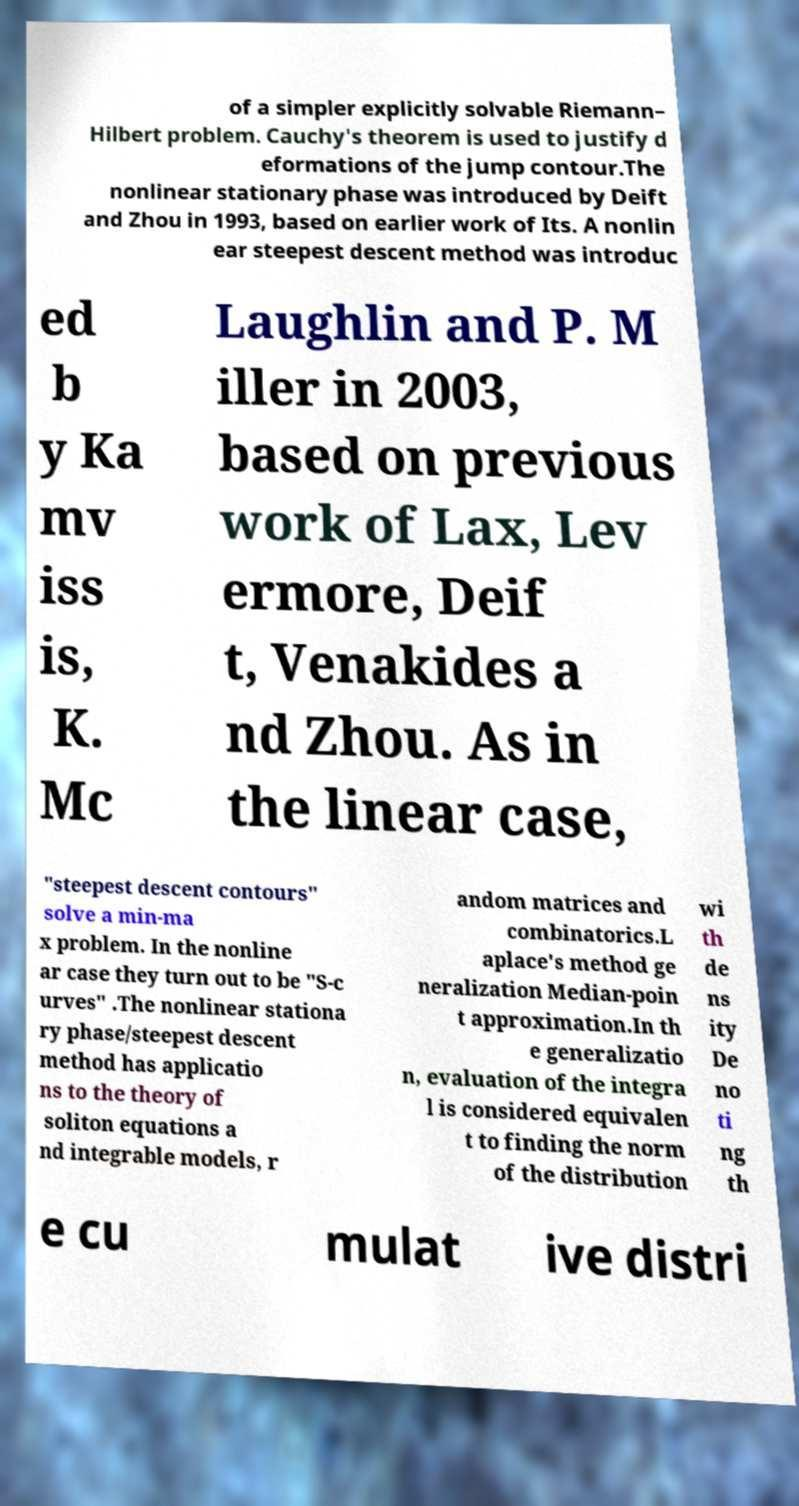Can you read and provide the text displayed in the image?This photo seems to have some interesting text. Can you extract and type it out for me? of a simpler explicitly solvable Riemann– Hilbert problem. Cauchy's theorem is used to justify d eformations of the jump contour.The nonlinear stationary phase was introduced by Deift and Zhou in 1993, based on earlier work of Its. A nonlin ear steepest descent method was introduc ed b y Ka mv iss is, K. Mc Laughlin and P. M iller in 2003, based on previous work of Lax, Lev ermore, Deif t, Venakides a nd Zhou. As in the linear case, "steepest descent contours" solve a min-ma x problem. In the nonline ar case they turn out to be "S-c urves" .The nonlinear stationa ry phase/steepest descent method has applicatio ns to the theory of soliton equations a nd integrable models, r andom matrices and combinatorics.L aplace's method ge neralization Median-poin t approximation.In th e generalizatio n, evaluation of the integra l is considered equivalen t to finding the norm of the distribution wi th de ns ity De no ti ng th e cu mulat ive distri 